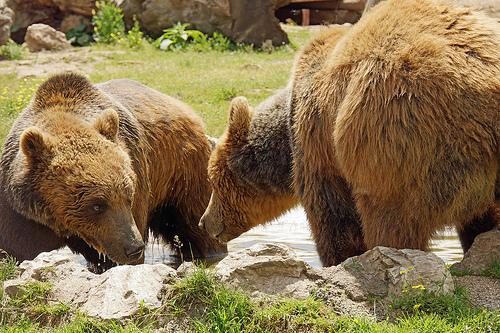Question: how many bears are there?
Choices:
A. 4.
B. 1.
C. 2.
D. 3.
Answer with the letter. Answer: C Question: where are the bears?
Choices:
A. On the rocks.
B. In the woods.
C. At the zoo.
D. On the glacier.
Answer with the letter. Answer: A Question: what are the bears doing?
Choices:
A. Eating.
B. Looking at eachother.
C. Killing another animal.
D. Playing.
Answer with the letter. Answer: B Question: why are the bears wet?
Choices:
A. It is raining.
B. Someone turned a hose on them.
C. They were bathing.
D. The river.
Answer with the letter. Answer: D Question: what color are the bears?
Choices:
A. Brown.
B. Black.
C. White.
D. Red.
Answer with the letter. Answer: A 